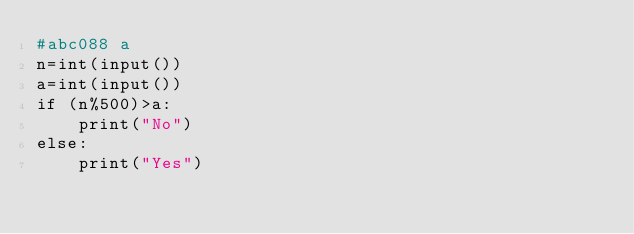<code> <loc_0><loc_0><loc_500><loc_500><_Python_>#abc088 a 
n=int(input())
a=int(input())
if (n%500)>a:
    print("No")
else:
    print("Yes")</code> 